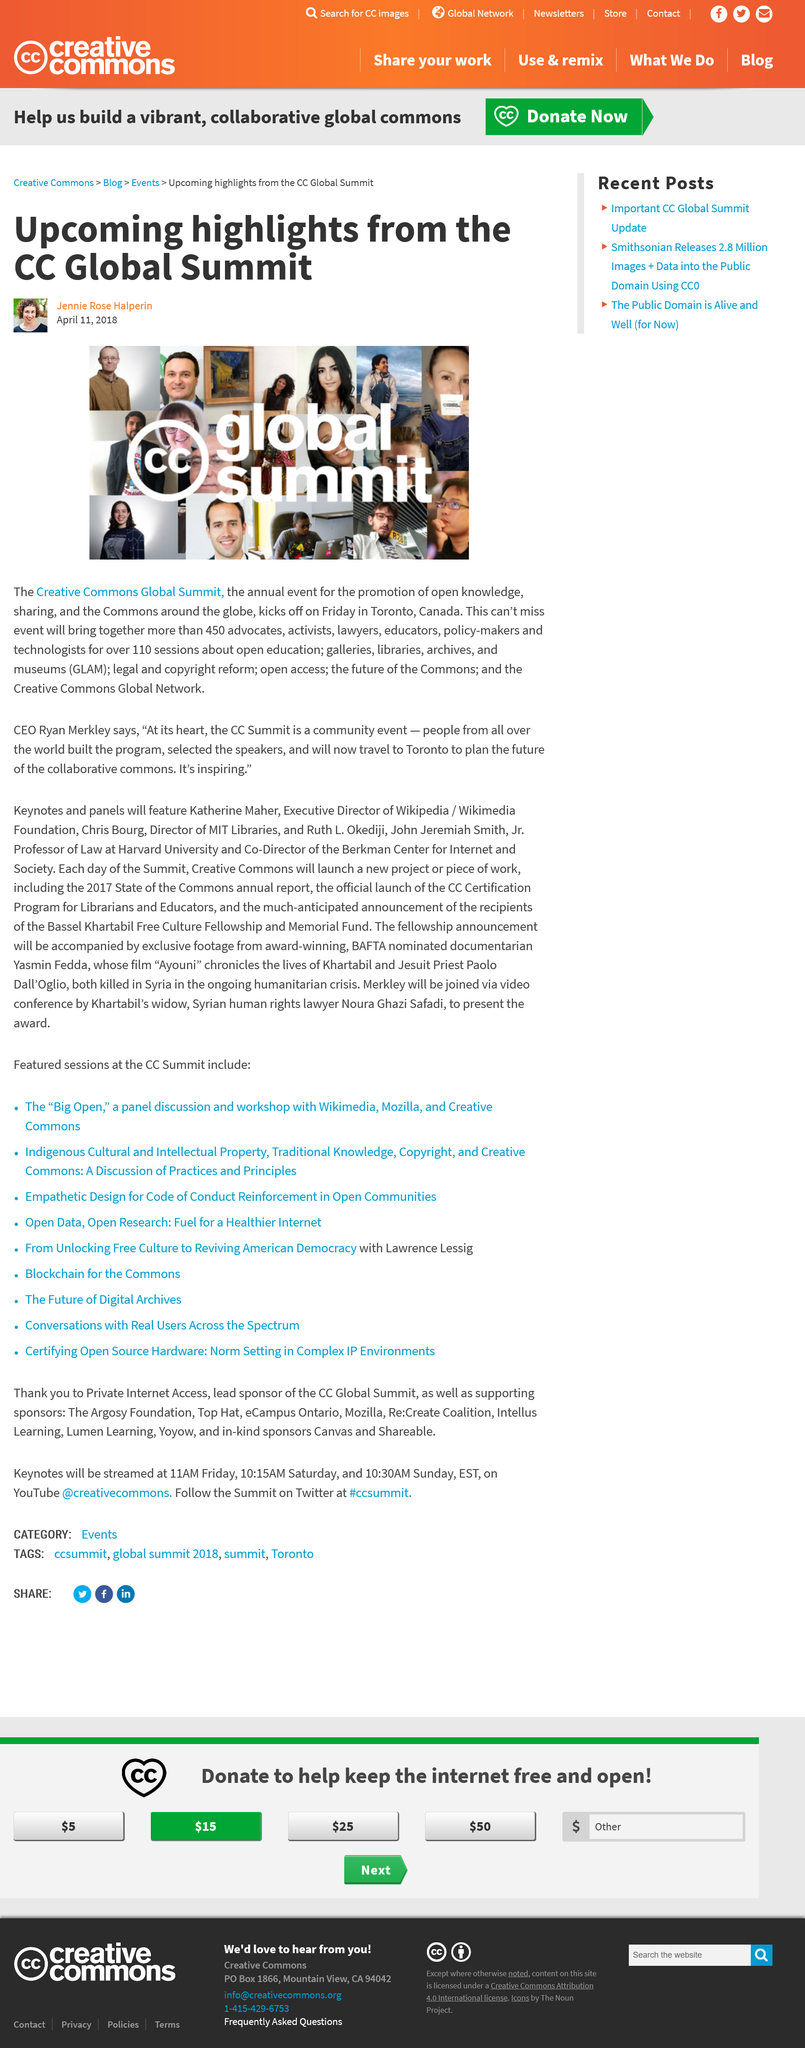Identify some key points in this picture. There are 110 sessions taking place at the Creative Commons Global Summit. The Creative Commons Global Summit gathers together professionals from various fields, including advocates, activists, lawyers, educators, policy-makers, and technologists, to discuss and promote the use and sharing of creative works under the Creative Commons license. The Creative Commons Global Summit is an annual gathering for the advancement of open knowledge sharing and promotion. 